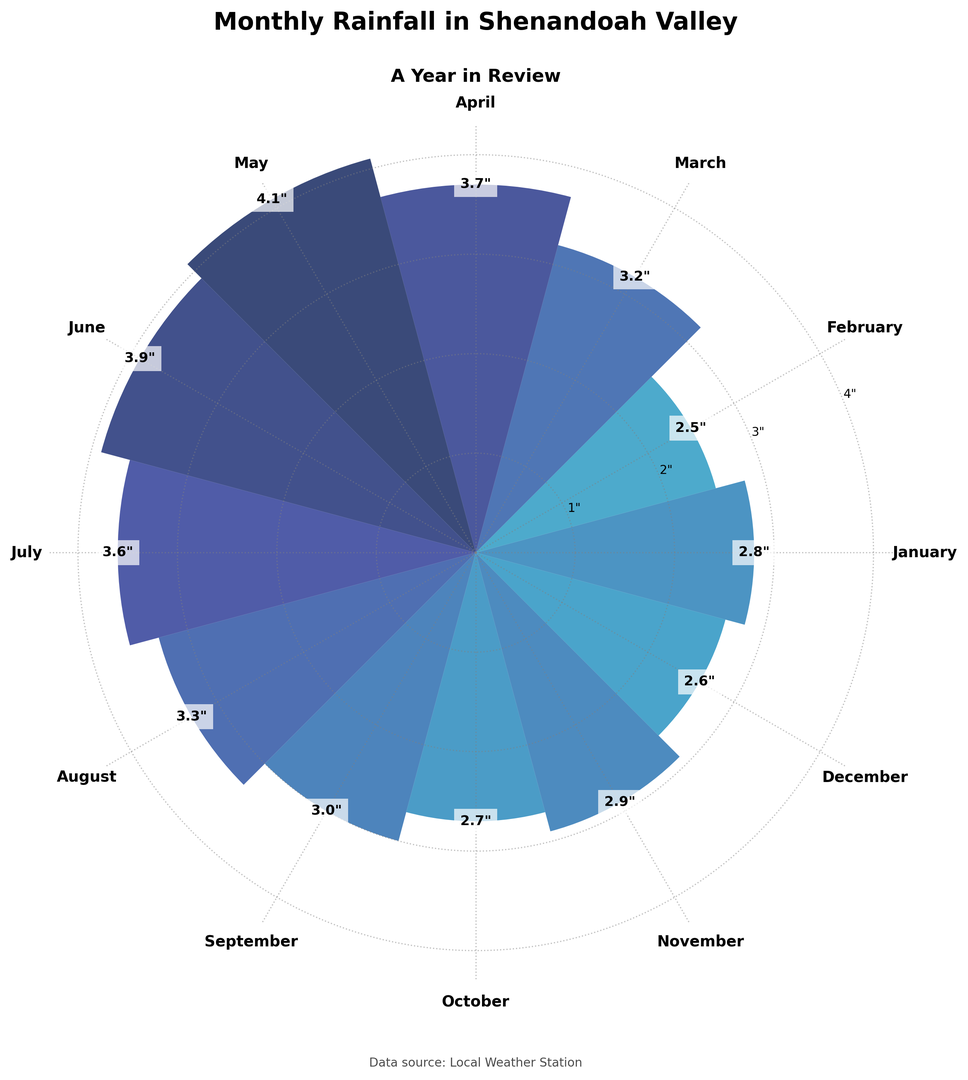Which month recorded the highest rainfall? The highest rainfall can be visually identified by looking at the bar that extends the farthest from the center of the rose chart. The bar representing May is the longest, indicating that May recorded the highest rainfall.
Answer: May Which month had less rainfall, August or October? Compare the bars for August and October. The bar for October is shorter (2.7 inches) than the bar for August (3.3 inches), indicating that October had less rainfall.
Answer: October What is the average rainfall for March, April, and May? To find the average rainfall, sum the rainfall values for March, April, and May (3.2 + 3.7 + 4.1) which equals 11.0 inches. Then, divide by 3 to find the average: 11.0 / 3 = 3.67 inches.
Answer: 3.67 inches Which two consecutive months have the largest difference in rainfall? Examine the differences between consecutive months' rainfall. The largest difference is between April (3.7 inches) and May (4.1 inches), with a difference of 1.6 inches.
Answer: April and May What is the total rainfall for the year? Sum the rainfall amounts for all months: 2.8 + 2.5 + 3.2 + 3.7 + 4.1 + 3.9 + 3.6 + 3.3 + 3.0 + 2.7 + 2.9 + 2.6 = 38.3 inches.
Answer: 38.3 inches Is the rainfall in February higher or lower than in December? Compare the bars for February and December. The bar for February is slightly higher (2.5 inches) compared to December (2.6 inches), indicating that February had slightly less rainfall.
Answer: Lower Which color bar is used to represent the month with the highest rainfall? Look at the color of the bar that extends the farthest from the center. The bar for May, which has the highest rainfall, is in a shade of blue.
Answer: Blue How does the rainfall in January compare to the rainfall in June? Compare the bars for January and June. The bar for June is taller (3.9 inches) than the bar for January (2.8 inches), indicating June had more rainfall.
Answer: June had more 